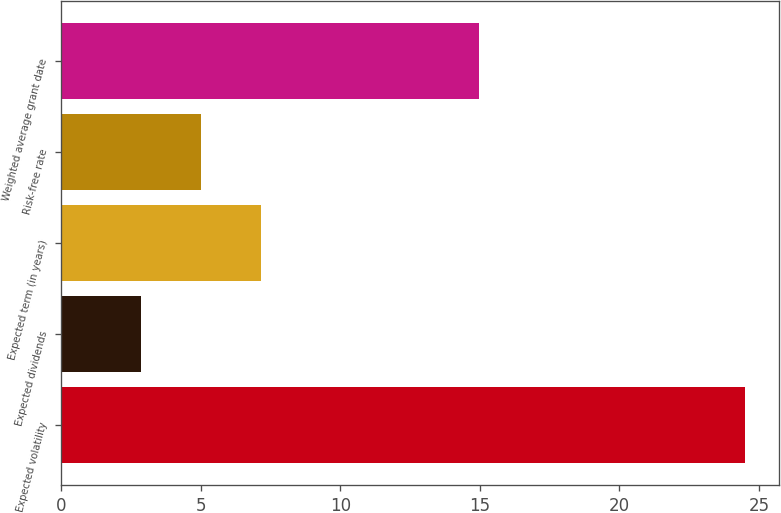Convert chart to OTSL. <chart><loc_0><loc_0><loc_500><loc_500><bar_chart><fcel>Expected volatility<fcel>Expected dividends<fcel>Expected term (in years)<fcel>Risk-free rate<fcel>Weighted average grant date<nl><fcel>24.5<fcel>2.86<fcel>7.18<fcel>5.02<fcel>14.98<nl></chart> 